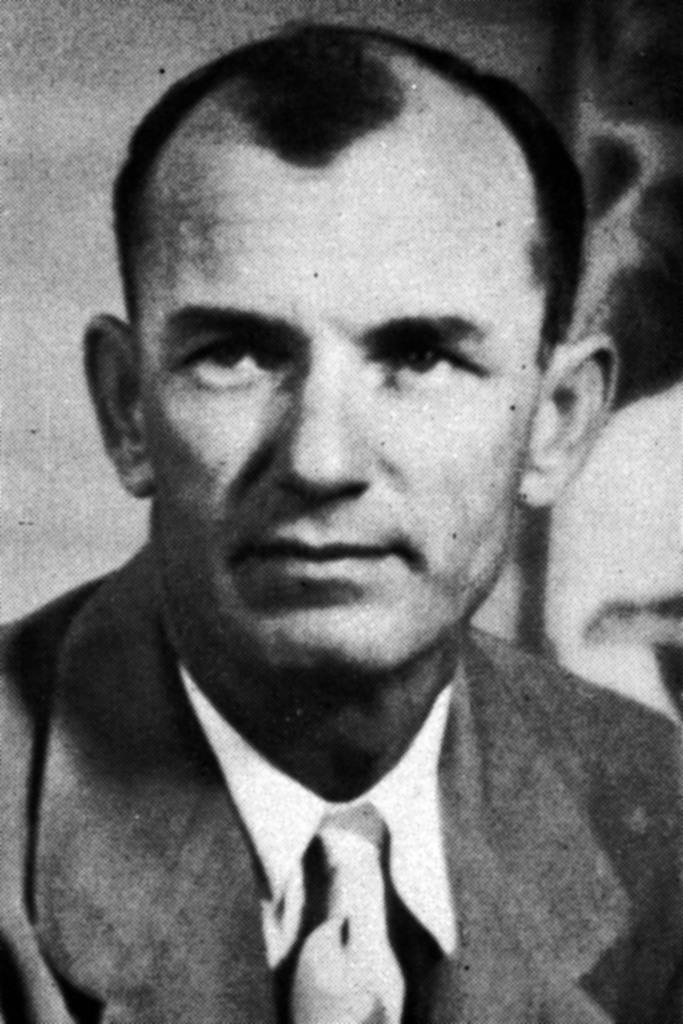What is the color scheme of the picture? The picture is black and white. Can you describe the main subject of the image? There is a person in the picture. What is the person wearing in the image? The person is wearing a suit. How many socks can be seen on the person in the image? There is no visible sock on the person in the image, as they are wearing a suit. What type of wealth is depicted in the image? There is no depiction of wealth in the image; it features a person wearing a suit in a black and white setting. 